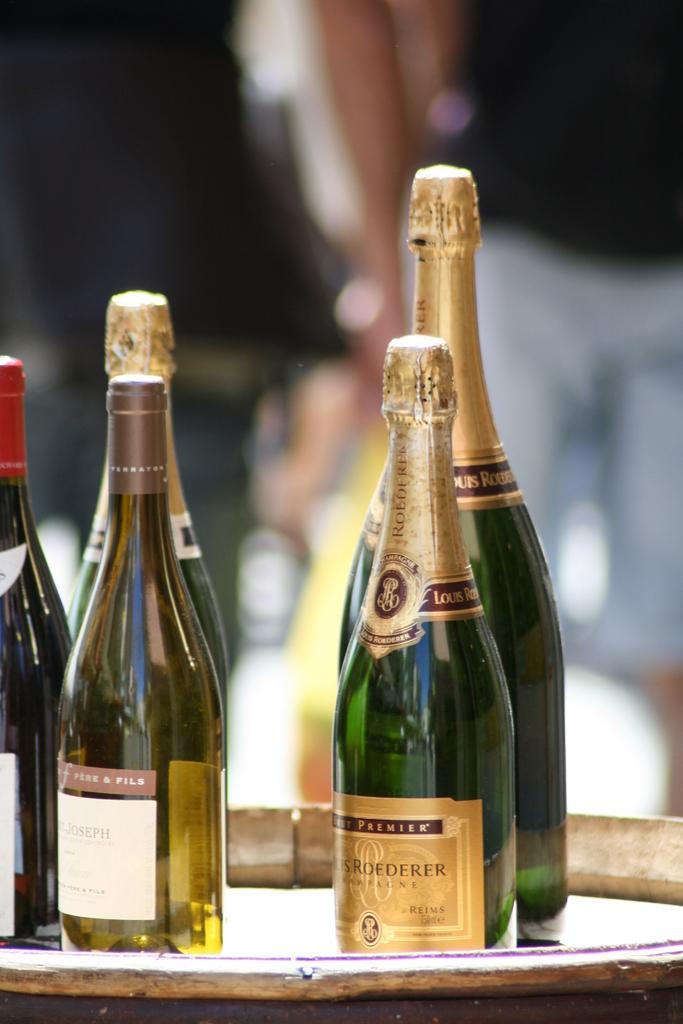Please provide a concise description of this image. This picture shows a bunch of wine bottles on the table 